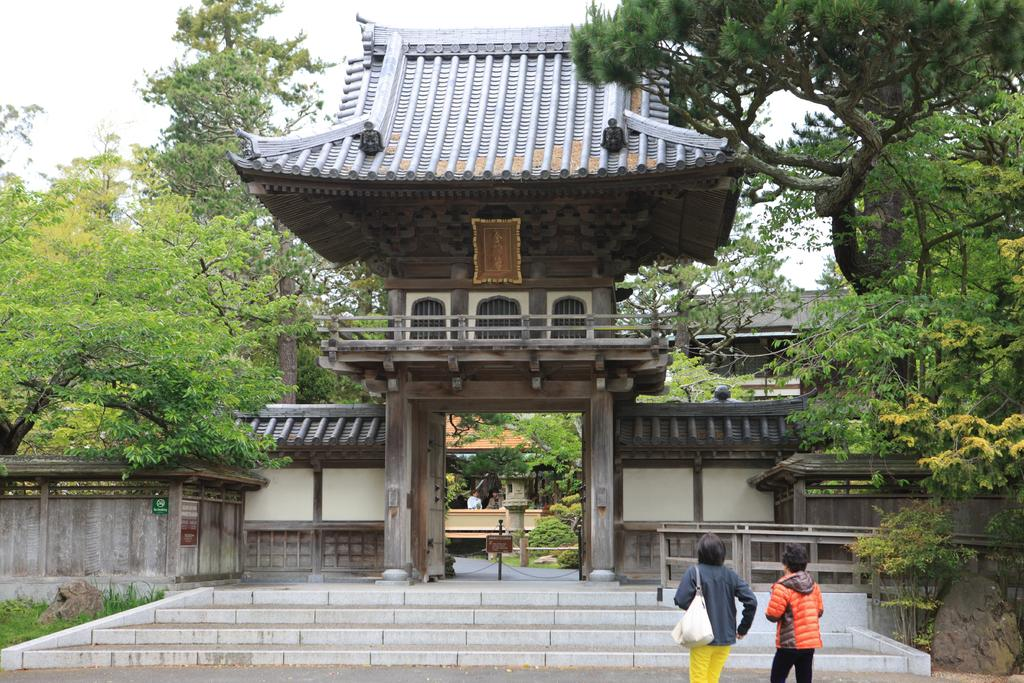How many people are in the image? There are two persons in the image. What are the persons doing in the image? The persons are approaching steps. Where do the steps lead to? The steps lead to the entrance of a building. What can be seen near the entrance of the building? There are trees beside the entrance of the building. What type of needle is being used by the persons in the image? There is no needle present in the image. What scene is depicted in the image? The image depicts two persons approaching steps that lead to the entrance of a building. 